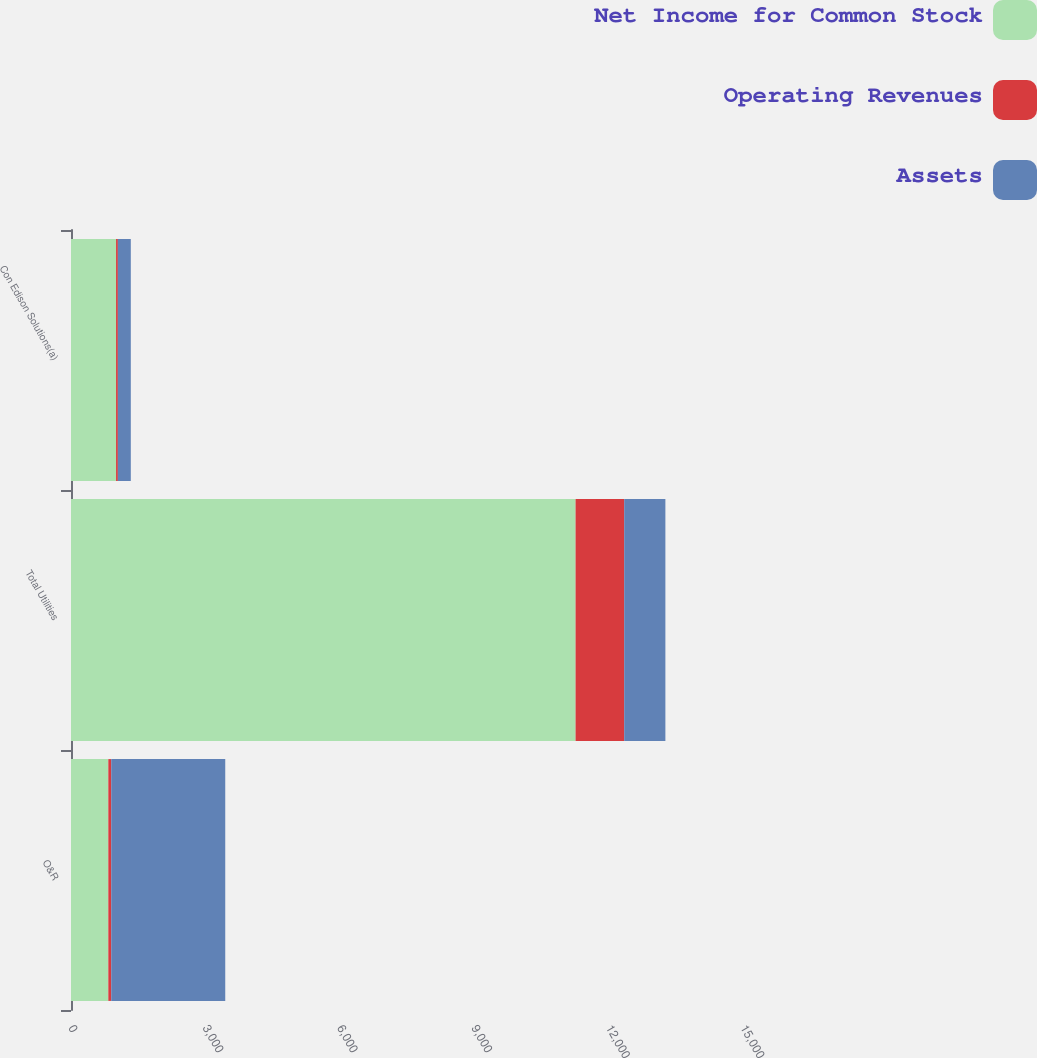<chart> <loc_0><loc_0><loc_500><loc_500><stacked_bar_chart><ecel><fcel>O&R<fcel>Total Utilities<fcel>Con Edison Solutions(a)<nl><fcel>Net Income for Common Stock<fcel>833<fcel>11263<fcel>1006<nl><fcel>Operating Revenues<fcel>65<fcel>1085<fcel>40<nl><fcel>Assets<fcel>2545<fcel>919.5<fcel>289<nl></chart> 